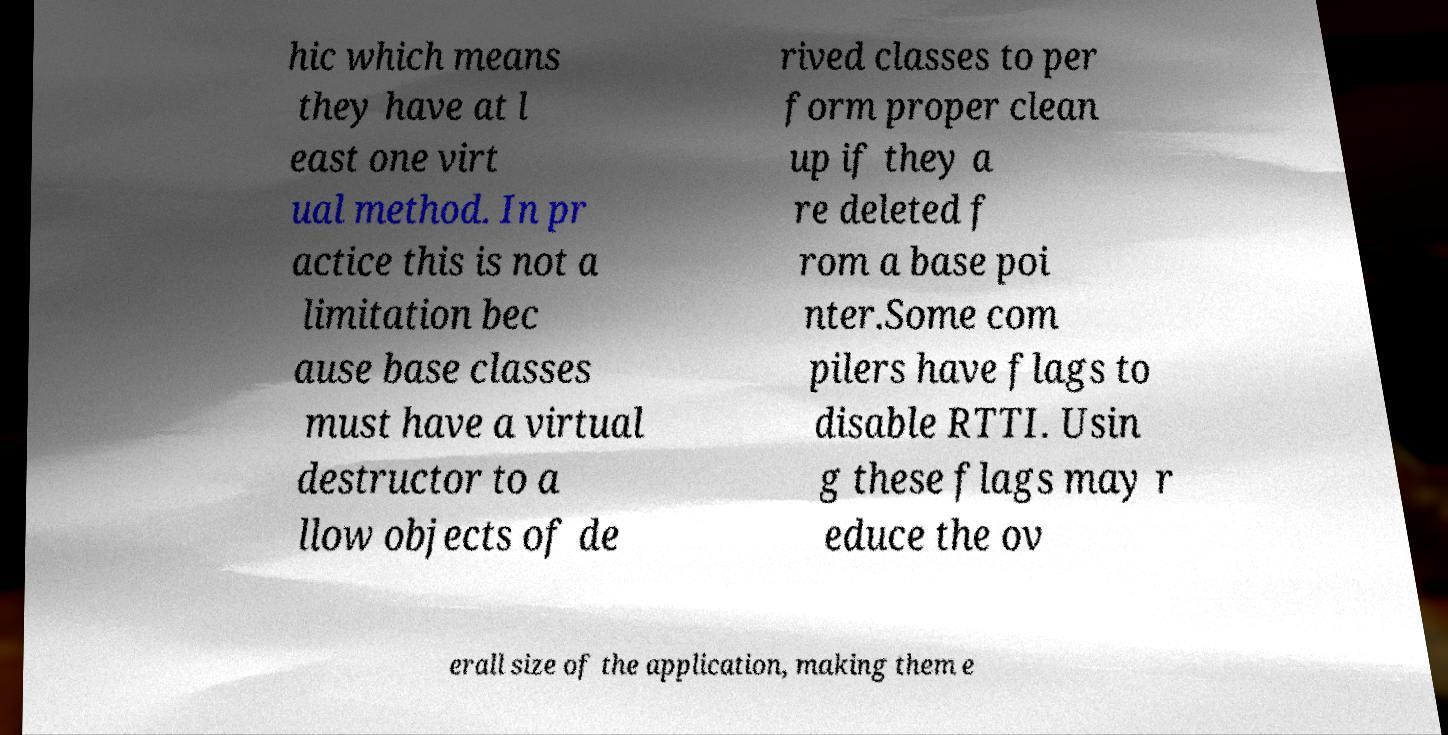Can you read and provide the text displayed in the image?This photo seems to have some interesting text. Can you extract and type it out for me? hic which means they have at l east one virt ual method. In pr actice this is not a limitation bec ause base classes must have a virtual destructor to a llow objects of de rived classes to per form proper clean up if they a re deleted f rom a base poi nter.Some com pilers have flags to disable RTTI. Usin g these flags may r educe the ov erall size of the application, making them e 